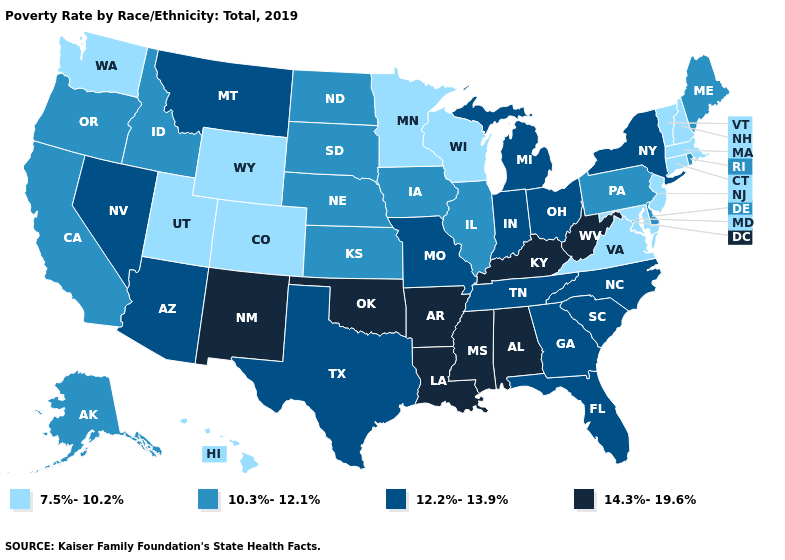What is the highest value in the USA?
Be succinct. 14.3%-19.6%. Which states have the lowest value in the USA?
Quick response, please. Colorado, Connecticut, Hawaii, Maryland, Massachusetts, Minnesota, New Hampshire, New Jersey, Utah, Vermont, Virginia, Washington, Wisconsin, Wyoming. Among the states that border Kansas , does Oklahoma have the highest value?
Be succinct. Yes. Among the states that border New Jersey , which have the highest value?
Answer briefly. New York. Is the legend a continuous bar?
Answer briefly. No. Does Maine have the same value as Kentucky?
Short answer required. No. What is the lowest value in the South?
Quick response, please. 7.5%-10.2%. What is the value of North Dakota?
Quick response, please. 10.3%-12.1%. Which states have the highest value in the USA?
Quick response, please. Alabama, Arkansas, Kentucky, Louisiana, Mississippi, New Mexico, Oklahoma, West Virginia. Which states have the lowest value in the USA?
Keep it brief. Colorado, Connecticut, Hawaii, Maryland, Massachusetts, Minnesota, New Hampshire, New Jersey, Utah, Vermont, Virginia, Washington, Wisconsin, Wyoming. Name the states that have a value in the range 14.3%-19.6%?
Short answer required. Alabama, Arkansas, Kentucky, Louisiana, Mississippi, New Mexico, Oklahoma, West Virginia. Does Virginia have a higher value than Mississippi?
Give a very brief answer. No. What is the value of North Dakota?
Keep it brief. 10.3%-12.1%. What is the highest value in the Northeast ?
Answer briefly. 12.2%-13.9%. What is the lowest value in the MidWest?
Keep it brief. 7.5%-10.2%. 